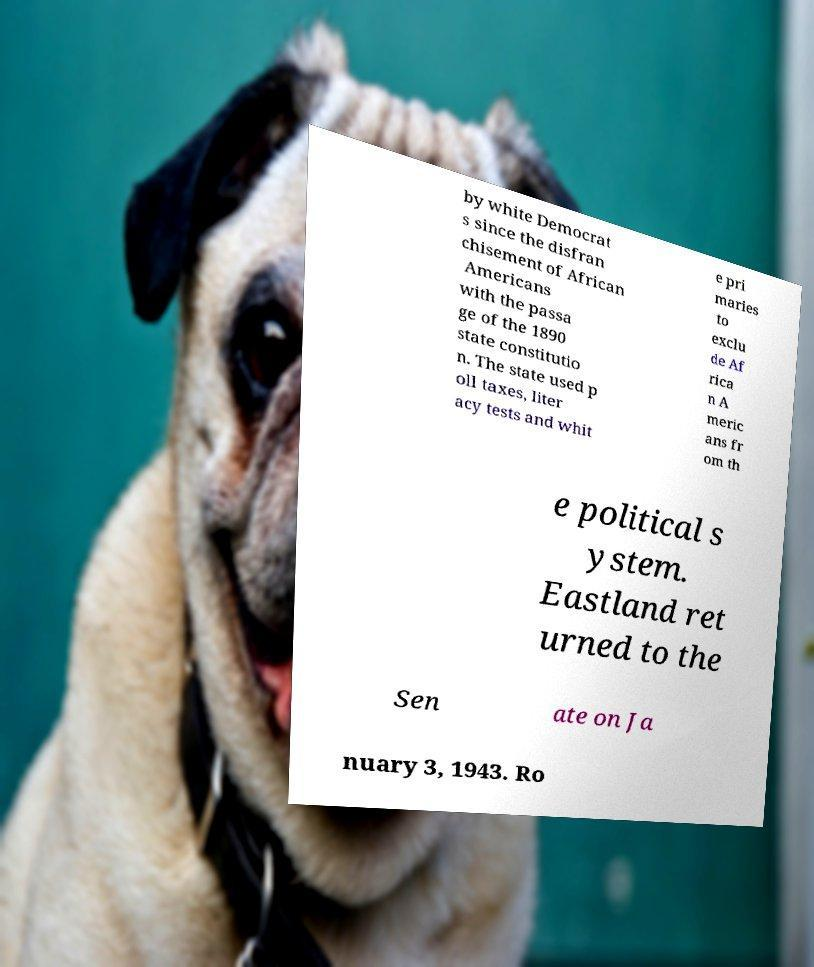Please identify and transcribe the text found in this image. by white Democrat s since the disfran chisement of African Americans with the passa ge of the 1890 state constitutio n. The state used p oll taxes, liter acy tests and whit e pri maries to exclu de Af rica n A meric ans fr om th e political s ystem. Eastland ret urned to the Sen ate on Ja nuary 3, 1943. Ro 